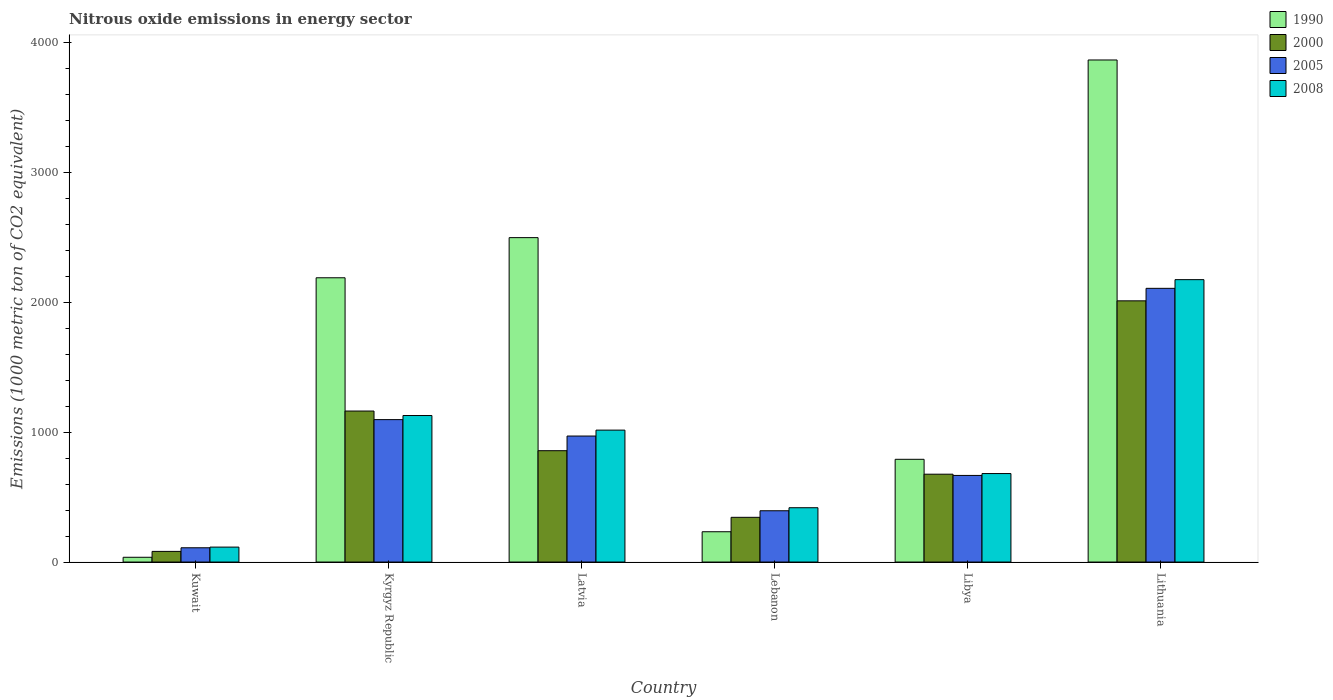How many groups of bars are there?
Give a very brief answer. 6. Are the number of bars per tick equal to the number of legend labels?
Give a very brief answer. Yes. Are the number of bars on each tick of the X-axis equal?
Give a very brief answer. Yes. How many bars are there on the 5th tick from the left?
Offer a terse response. 4. How many bars are there on the 3rd tick from the right?
Provide a succinct answer. 4. What is the label of the 4th group of bars from the left?
Offer a very short reply. Lebanon. In how many cases, is the number of bars for a given country not equal to the number of legend labels?
Your answer should be compact. 0. What is the amount of nitrous oxide emitted in 2008 in Latvia?
Your response must be concise. 1015.5. Across all countries, what is the maximum amount of nitrous oxide emitted in 2005?
Your answer should be very brief. 2107. Across all countries, what is the minimum amount of nitrous oxide emitted in 2005?
Ensure brevity in your answer.  109.8. In which country was the amount of nitrous oxide emitted in 1990 maximum?
Keep it short and to the point. Lithuania. In which country was the amount of nitrous oxide emitted in 2000 minimum?
Keep it short and to the point. Kuwait. What is the total amount of nitrous oxide emitted in 2005 in the graph?
Your response must be concise. 5344.6. What is the difference between the amount of nitrous oxide emitted in 2000 in Kyrgyz Republic and that in Libya?
Offer a terse response. 486.2. What is the difference between the amount of nitrous oxide emitted in 2008 in Kuwait and the amount of nitrous oxide emitted in 2005 in Lebanon?
Make the answer very short. -279.8. What is the average amount of nitrous oxide emitted in 1990 per country?
Make the answer very short. 1601.9. What is the difference between the amount of nitrous oxide emitted of/in 2005 and amount of nitrous oxide emitted of/in 1990 in Kyrgyz Republic?
Offer a terse response. -1091.9. What is the ratio of the amount of nitrous oxide emitted in 2008 in Kyrgyz Republic to that in Latvia?
Make the answer very short. 1.11. What is the difference between the highest and the second highest amount of nitrous oxide emitted in 2008?
Ensure brevity in your answer.  -1158.4. What is the difference between the highest and the lowest amount of nitrous oxide emitted in 2005?
Provide a short and direct response. 1997.2. In how many countries, is the amount of nitrous oxide emitted in 2008 greater than the average amount of nitrous oxide emitted in 2008 taken over all countries?
Offer a terse response. 3. Is the sum of the amount of nitrous oxide emitted in 2008 in Lebanon and Lithuania greater than the maximum amount of nitrous oxide emitted in 2005 across all countries?
Give a very brief answer. Yes. Is it the case that in every country, the sum of the amount of nitrous oxide emitted in 2005 and amount of nitrous oxide emitted in 2008 is greater than the sum of amount of nitrous oxide emitted in 1990 and amount of nitrous oxide emitted in 2000?
Make the answer very short. No. What does the 3rd bar from the right in Kuwait represents?
Give a very brief answer. 2000. How many bars are there?
Offer a terse response. 24. Are all the bars in the graph horizontal?
Offer a very short reply. No. How many countries are there in the graph?
Your answer should be very brief. 6. Are the values on the major ticks of Y-axis written in scientific E-notation?
Provide a short and direct response. No. Does the graph contain grids?
Make the answer very short. No. How many legend labels are there?
Give a very brief answer. 4. What is the title of the graph?
Make the answer very short. Nitrous oxide emissions in energy sector. What is the label or title of the Y-axis?
Offer a terse response. Emissions (1000 metric ton of CO2 equivalent). What is the Emissions (1000 metric ton of CO2 equivalent) in 1990 in Kuwait?
Offer a terse response. 36.7. What is the Emissions (1000 metric ton of CO2 equivalent) of 2000 in Kuwait?
Offer a terse response. 81.9. What is the Emissions (1000 metric ton of CO2 equivalent) of 2005 in Kuwait?
Offer a very short reply. 109.8. What is the Emissions (1000 metric ton of CO2 equivalent) in 2008 in Kuwait?
Provide a short and direct response. 114.9. What is the Emissions (1000 metric ton of CO2 equivalent) of 1990 in Kyrgyz Republic?
Keep it short and to the point. 2188.3. What is the Emissions (1000 metric ton of CO2 equivalent) of 2000 in Kyrgyz Republic?
Offer a very short reply. 1162.4. What is the Emissions (1000 metric ton of CO2 equivalent) of 2005 in Kyrgyz Republic?
Provide a short and direct response. 1096.4. What is the Emissions (1000 metric ton of CO2 equivalent) in 2008 in Kyrgyz Republic?
Offer a very short reply. 1127.9. What is the Emissions (1000 metric ton of CO2 equivalent) of 1990 in Latvia?
Keep it short and to the point. 2497.4. What is the Emissions (1000 metric ton of CO2 equivalent) in 2000 in Latvia?
Offer a terse response. 857.1. What is the Emissions (1000 metric ton of CO2 equivalent) of 2005 in Latvia?
Provide a short and direct response. 970. What is the Emissions (1000 metric ton of CO2 equivalent) of 2008 in Latvia?
Offer a terse response. 1015.5. What is the Emissions (1000 metric ton of CO2 equivalent) in 1990 in Lebanon?
Your answer should be compact. 233.2. What is the Emissions (1000 metric ton of CO2 equivalent) of 2000 in Lebanon?
Your response must be concise. 344.2. What is the Emissions (1000 metric ton of CO2 equivalent) in 2005 in Lebanon?
Your answer should be compact. 394.7. What is the Emissions (1000 metric ton of CO2 equivalent) of 2008 in Lebanon?
Provide a short and direct response. 418.1. What is the Emissions (1000 metric ton of CO2 equivalent) in 1990 in Libya?
Keep it short and to the point. 790.8. What is the Emissions (1000 metric ton of CO2 equivalent) in 2000 in Libya?
Your answer should be very brief. 676.2. What is the Emissions (1000 metric ton of CO2 equivalent) of 2005 in Libya?
Ensure brevity in your answer.  666.7. What is the Emissions (1000 metric ton of CO2 equivalent) in 2008 in Libya?
Keep it short and to the point. 681.1. What is the Emissions (1000 metric ton of CO2 equivalent) of 1990 in Lithuania?
Make the answer very short. 3865. What is the Emissions (1000 metric ton of CO2 equivalent) in 2000 in Lithuania?
Your response must be concise. 2010.8. What is the Emissions (1000 metric ton of CO2 equivalent) in 2005 in Lithuania?
Provide a succinct answer. 2107. What is the Emissions (1000 metric ton of CO2 equivalent) of 2008 in Lithuania?
Provide a succinct answer. 2173.9. Across all countries, what is the maximum Emissions (1000 metric ton of CO2 equivalent) in 1990?
Your answer should be very brief. 3865. Across all countries, what is the maximum Emissions (1000 metric ton of CO2 equivalent) of 2000?
Keep it short and to the point. 2010.8. Across all countries, what is the maximum Emissions (1000 metric ton of CO2 equivalent) of 2005?
Make the answer very short. 2107. Across all countries, what is the maximum Emissions (1000 metric ton of CO2 equivalent) in 2008?
Provide a short and direct response. 2173.9. Across all countries, what is the minimum Emissions (1000 metric ton of CO2 equivalent) of 1990?
Provide a short and direct response. 36.7. Across all countries, what is the minimum Emissions (1000 metric ton of CO2 equivalent) in 2000?
Make the answer very short. 81.9. Across all countries, what is the minimum Emissions (1000 metric ton of CO2 equivalent) of 2005?
Provide a succinct answer. 109.8. Across all countries, what is the minimum Emissions (1000 metric ton of CO2 equivalent) of 2008?
Give a very brief answer. 114.9. What is the total Emissions (1000 metric ton of CO2 equivalent) in 1990 in the graph?
Your answer should be very brief. 9611.4. What is the total Emissions (1000 metric ton of CO2 equivalent) in 2000 in the graph?
Your answer should be very brief. 5132.6. What is the total Emissions (1000 metric ton of CO2 equivalent) of 2005 in the graph?
Your answer should be compact. 5344.6. What is the total Emissions (1000 metric ton of CO2 equivalent) in 2008 in the graph?
Your response must be concise. 5531.4. What is the difference between the Emissions (1000 metric ton of CO2 equivalent) of 1990 in Kuwait and that in Kyrgyz Republic?
Ensure brevity in your answer.  -2151.6. What is the difference between the Emissions (1000 metric ton of CO2 equivalent) of 2000 in Kuwait and that in Kyrgyz Republic?
Provide a succinct answer. -1080.5. What is the difference between the Emissions (1000 metric ton of CO2 equivalent) of 2005 in Kuwait and that in Kyrgyz Republic?
Your response must be concise. -986.6. What is the difference between the Emissions (1000 metric ton of CO2 equivalent) of 2008 in Kuwait and that in Kyrgyz Republic?
Provide a succinct answer. -1013. What is the difference between the Emissions (1000 metric ton of CO2 equivalent) in 1990 in Kuwait and that in Latvia?
Give a very brief answer. -2460.7. What is the difference between the Emissions (1000 metric ton of CO2 equivalent) of 2000 in Kuwait and that in Latvia?
Your response must be concise. -775.2. What is the difference between the Emissions (1000 metric ton of CO2 equivalent) of 2005 in Kuwait and that in Latvia?
Your answer should be very brief. -860.2. What is the difference between the Emissions (1000 metric ton of CO2 equivalent) in 2008 in Kuwait and that in Latvia?
Offer a terse response. -900.6. What is the difference between the Emissions (1000 metric ton of CO2 equivalent) of 1990 in Kuwait and that in Lebanon?
Your answer should be very brief. -196.5. What is the difference between the Emissions (1000 metric ton of CO2 equivalent) of 2000 in Kuwait and that in Lebanon?
Ensure brevity in your answer.  -262.3. What is the difference between the Emissions (1000 metric ton of CO2 equivalent) of 2005 in Kuwait and that in Lebanon?
Your answer should be compact. -284.9. What is the difference between the Emissions (1000 metric ton of CO2 equivalent) of 2008 in Kuwait and that in Lebanon?
Offer a terse response. -303.2. What is the difference between the Emissions (1000 metric ton of CO2 equivalent) of 1990 in Kuwait and that in Libya?
Your answer should be very brief. -754.1. What is the difference between the Emissions (1000 metric ton of CO2 equivalent) of 2000 in Kuwait and that in Libya?
Your response must be concise. -594.3. What is the difference between the Emissions (1000 metric ton of CO2 equivalent) of 2005 in Kuwait and that in Libya?
Offer a terse response. -556.9. What is the difference between the Emissions (1000 metric ton of CO2 equivalent) of 2008 in Kuwait and that in Libya?
Your response must be concise. -566.2. What is the difference between the Emissions (1000 metric ton of CO2 equivalent) of 1990 in Kuwait and that in Lithuania?
Your answer should be compact. -3828.3. What is the difference between the Emissions (1000 metric ton of CO2 equivalent) of 2000 in Kuwait and that in Lithuania?
Your response must be concise. -1928.9. What is the difference between the Emissions (1000 metric ton of CO2 equivalent) of 2005 in Kuwait and that in Lithuania?
Ensure brevity in your answer.  -1997.2. What is the difference between the Emissions (1000 metric ton of CO2 equivalent) of 2008 in Kuwait and that in Lithuania?
Give a very brief answer. -2059. What is the difference between the Emissions (1000 metric ton of CO2 equivalent) in 1990 in Kyrgyz Republic and that in Latvia?
Your answer should be compact. -309.1. What is the difference between the Emissions (1000 metric ton of CO2 equivalent) of 2000 in Kyrgyz Republic and that in Latvia?
Offer a terse response. 305.3. What is the difference between the Emissions (1000 metric ton of CO2 equivalent) in 2005 in Kyrgyz Republic and that in Latvia?
Your answer should be very brief. 126.4. What is the difference between the Emissions (1000 metric ton of CO2 equivalent) of 2008 in Kyrgyz Republic and that in Latvia?
Provide a succinct answer. 112.4. What is the difference between the Emissions (1000 metric ton of CO2 equivalent) of 1990 in Kyrgyz Republic and that in Lebanon?
Offer a very short reply. 1955.1. What is the difference between the Emissions (1000 metric ton of CO2 equivalent) in 2000 in Kyrgyz Republic and that in Lebanon?
Provide a short and direct response. 818.2. What is the difference between the Emissions (1000 metric ton of CO2 equivalent) of 2005 in Kyrgyz Republic and that in Lebanon?
Offer a terse response. 701.7. What is the difference between the Emissions (1000 metric ton of CO2 equivalent) of 2008 in Kyrgyz Republic and that in Lebanon?
Your answer should be very brief. 709.8. What is the difference between the Emissions (1000 metric ton of CO2 equivalent) in 1990 in Kyrgyz Republic and that in Libya?
Make the answer very short. 1397.5. What is the difference between the Emissions (1000 metric ton of CO2 equivalent) in 2000 in Kyrgyz Republic and that in Libya?
Offer a terse response. 486.2. What is the difference between the Emissions (1000 metric ton of CO2 equivalent) in 2005 in Kyrgyz Republic and that in Libya?
Your response must be concise. 429.7. What is the difference between the Emissions (1000 metric ton of CO2 equivalent) of 2008 in Kyrgyz Republic and that in Libya?
Provide a succinct answer. 446.8. What is the difference between the Emissions (1000 metric ton of CO2 equivalent) of 1990 in Kyrgyz Republic and that in Lithuania?
Your answer should be compact. -1676.7. What is the difference between the Emissions (1000 metric ton of CO2 equivalent) in 2000 in Kyrgyz Republic and that in Lithuania?
Provide a short and direct response. -848.4. What is the difference between the Emissions (1000 metric ton of CO2 equivalent) in 2005 in Kyrgyz Republic and that in Lithuania?
Your response must be concise. -1010.6. What is the difference between the Emissions (1000 metric ton of CO2 equivalent) in 2008 in Kyrgyz Republic and that in Lithuania?
Offer a very short reply. -1046. What is the difference between the Emissions (1000 metric ton of CO2 equivalent) in 1990 in Latvia and that in Lebanon?
Keep it short and to the point. 2264.2. What is the difference between the Emissions (1000 metric ton of CO2 equivalent) in 2000 in Latvia and that in Lebanon?
Your answer should be compact. 512.9. What is the difference between the Emissions (1000 metric ton of CO2 equivalent) in 2005 in Latvia and that in Lebanon?
Provide a short and direct response. 575.3. What is the difference between the Emissions (1000 metric ton of CO2 equivalent) of 2008 in Latvia and that in Lebanon?
Provide a succinct answer. 597.4. What is the difference between the Emissions (1000 metric ton of CO2 equivalent) of 1990 in Latvia and that in Libya?
Offer a very short reply. 1706.6. What is the difference between the Emissions (1000 metric ton of CO2 equivalent) in 2000 in Latvia and that in Libya?
Offer a terse response. 180.9. What is the difference between the Emissions (1000 metric ton of CO2 equivalent) in 2005 in Latvia and that in Libya?
Your answer should be compact. 303.3. What is the difference between the Emissions (1000 metric ton of CO2 equivalent) in 2008 in Latvia and that in Libya?
Your answer should be very brief. 334.4. What is the difference between the Emissions (1000 metric ton of CO2 equivalent) in 1990 in Latvia and that in Lithuania?
Your answer should be very brief. -1367.6. What is the difference between the Emissions (1000 metric ton of CO2 equivalent) in 2000 in Latvia and that in Lithuania?
Offer a terse response. -1153.7. What is the difference between the Emissions (1000 metric ton of CO2 equivalent) in 2005 in Latvia and that in Lithuania?
Your answer should be compact. -1137. What is the difference between the Emissions (1000 metric ton of CO2 equivalent) of 2008 in Latvia and that in Lithuania?
Offer a terse response. -1158.4. What is the difference between the Emissions (1000 metric ton of CO2 equivalent) of 1990 in Lebanon and that in Libya?
Your answer should be very brief. -557.6. What is the difference between the Emissions (1000 metric ton of CO2 equivalent) in 2000 in Lebanon and that in Libya?
Provide a short and direct response. -332. What is the difference between the Emissions (1000 metric ton of CO2 equivalent) of 2005 in Lebanon and that in Libya?
Your answer should be very brief. -272. What is the difference between the Emissions (1000 metric ton of CO2 equivalent) of 2008 in Lebanon and that in Libya?
Give a very brief answer. -263. What is the difference between the Emissions (1000 metric ton of CO2 equivalent) of 1990 in Lebanon and that in Lithuania?
Provide a succinct answer. -3631.8. What is the difference between the Emissions (1000 metric ton of CO2 equivalent) of 2000 in Lebanon and that in Lithuania?
Provide a succinct answer. -1666.6. What is the difference between the Emissions (1000 metric ton of CO2 equivalent) of 2005 in Lebanon and that in Lithuania?
Offer a very short reply. -1712.3. What is the difference between the Emissions (1000 metric ton of CO2 equivalent) in 2008 in Lebanon and that in Lithuania?
Give a very brief answer. -1755.8. What is the difference between the Emissions (1000 metric ton of CO2 equivalent) of 1990 in Libya and that in Lithuania?
Provide a short and direct response. -3074.2. What is the difference between the Emissions (1000 metric ton of CO2 equivalent) in 2000 in Libya and that in Lithuania?
Offer a very short reply. -1334.6. What is the difference between the Emissions (1000 metric ton of CO2 equivalent) in 2005 in Libya and that in Lithuania?
Provide a succinct answer. -1440.3. What is the difference between the Emissions (1000 metric ton of CO2 equivalent) of 2008 in Libya and that in Lithuania?
Offer a terse response. -1492.8. What is the difference between the Emissions (1000 metric ton of CO2 equivalent) of 1990 in Kuwait and the Emissions (1000 metric ton of CO2 equivalent) of 2000 in Kyrgyz Republic?
Offer a terse response. -1125.7. What is the difference between the Emissions (1000 metric ton of CO2 equivalent) of 1990 in Kuwait and the Emissions (1000 metric ton of CO2 equivalent) of 2005 in Kyrgyz Republic?
Your response must be concise. -1059.7. What is the difference between the Emissions (1000 metric ton of CO2 equivalent) in 1990 in Kuwait and the Emissions (1000 metric ton of CO2 equivalent) in 2008 in Kyrgyz Republic?
Keep it short and to the point. -1091.2. What is the difference between the Emissions (1000 metric ton of CO2 equivalent) of 2000 in Kuwait and the Emissions (1000 metric ton of CO2 equivalent) of 2005 in Kyrgyz Republic?
Ensure brevity in your answer.  -1014.5. What is the difference between the Emissions (1000 metric ton of CO2 equivalent) in 2000 in Kuwait and the Emissions (1000 metric ton of CO2 equivalent) in 2008 in Kyrgyz Republic?
Give a very brief answer. -1046. What is the difference between the Emissions (1000 metric ton of CO2 equivalent) in 2005 in Kuwait and the Emissions (1000 metric ton of CO2 equivalent) in 2008 in Kyrgyz Republic?
Your answer should be compact. -1018.1. What is the difference between the Emissions (1000 metric ton of CO2 equivalent) of 1990 in Kuwait and the Emissions (1000 metric ton of CO2 equivalent) of 2000 in Latvia?
Keep it short and to the point. -820.4. What is the difference between the Emissions (1000 metric ton of CO2 equivalent) in 1990 in Kuwait and the Emissions (1000 metric ton of CO2 equivalent) in 2005 in Latvia?
Make the answer very short. -933.3. What is the difference between the Emissions (1000 metric ton of CO2 equivalent) in 1990 in Kuwait and the Emissions (1000 metric ton of CO2 equivalent) in 2008 in Latvia?
Your response must be concise. -978.8. What is the difference between the Emissions (1000 metric ton of CO2 equivalent) in 2000 in Kuwait and the Emissions (1000 metric ton of CO2 equivalent) in 2005 in Latvia?
Ensure brevity in your answer.  -888.1. What is the difference between the Emissions (1000 metric ton of CO2 equivalent) in 2000 in Kuwait and the Emissions (1000 metric ton of CO2 equivalent) in 2008 in Latvia?
Your answer should be very brief. -933.6. What is the difference between the Emissions (1000 metric ton of CO2 equivalent) in 2005 in Kuwait and the Emissions (1000 metric ton of CO2 equivalent) in 2008 in Latvia?
Ensure brevity in your answer.  -905.7. What is the difference between the Emissions (1000 metric ton of CO2 equivalent) in 1990 in Kuwait and the Emissions (1000 metric ton of CO2 equivalent) in 2000 in Lebanon?
Ensure brevity in your answer.  -307.5. What is the difference between the Emissions (1000 metric ton of CO2 equivalent) of 1990 in Kuwait and the Emissions (1000 metric ton of CO2 equivalent) of 2005 in Lebanon?
Keep it short and to the point. -358. What is the difference between the Emissions (1000 metric ton of CO2 equivalent) of 1990 in Kuwait and the Emissions (1000 metric ton of CO2 equivalent) of 2008 in Lebanon?
Your response must be concise. -381.4. What is the difference between the Emissions (1000 metric ton of CO2 equivalent) in 2000 in Kuwait and the Emissions (1000 metric ton of CO2 equivalent) in 2005 in Lebanon?
Your response must be concise. -312.8. What is the difference between the Emissions (1000 metric ton of CO2 equivalent) in 2000 in Kuwait and the Emissions (1000 metric ton of CO2 equivalent) in 2008 in Lebanon?
Offer a terse response. -336.2. What is the difference between the Emissions (1000 metric ton of CO2 equivalent) in 2005 in Kuwait and the Emissions (1000 metric ton of CO2 equivalent) in 2008 in Lebanon?
Give a very brief answer. -308.3. What is the difference between the Emissions (1000 metric ton of CO2 equivalent) of 1990 in Kuwait and the Emissions (1000 metric ton of CO2 equivalent) of 2000 in Libya?
Make the answer very short. -639.5. What is the difference between the Emissions (1000 metric ton of CO2 equivalent) in 1990 in Kuwait and the Emissions (1000 metric ton of CO2 equivalent) in 2005 in Libya?
Offer a very short reply. -630. What is the difference between the Emissions (1000 metric ton of CO2 equivalent) in 1990 in Kuwait and the Emissions (1000 metric ton of CO2 equivalent) in 2008 in Libya?
Make the answer very short. -644.4. What is the difference between the Emissions (1000 metric ton of CO2 equivalent) in 2000 in Kuwait and the Emissions (1000 metric ton of CO2 equivalent) in 2005 in Libya?
Provide a succinct answer. -584.8. What is the difference between the Emissions (1000 metric ton of CO2 equivalent) of 2000 in Kuwait and the Emissions (1000 metric ton of CO2 equivalent) of 2008 in Libya?
Offer a terse response. -599.2. What is the difference between the Emissions (1000 metric ton of CO2 equivalent) in 2005 in Kuwait and the Emissions (1000 metric ton of CO2 equivalent) in 2008 in Libya?
Provide a short and direct response. -571.3. What is the difference between the Emissions (1000 metric ton of CO2 equivalent) in 1990 in Kuwait and the Emissions (1000 metric ton of CO2 equivalent) in 2000 in Lithuania?
Provide a short and direct response. -1974.1. What is the difference between the Emissions (1000 metric ton of CO2 equivalent) of 1990 in Kuwait and the Emissions (1000 metric ton of CO2 equivalent) of 2005 in Lithuania?
Give a very brief answer. -2070.3. What is the difference between the Emissions (1000 metric ton of CO2 equivalent) in 1990 in Kuwait and the Emissions (1000 metric ton of CO2 equivalent) in 2008 in Lithuania?
Make the answer very short. -2137.2. What is the difference between the Emissions (1000 metric ton of CO2 equivalent) in 2000 in Kuwait and the Emissions (1000 metric ton of CO2 equivalent) in 2005 in Lithuania?
Make the answer very short. -2025.1. What is the difference between the Emissions (1000 metric ton of CO2 equivalent) in 2000 in Kuwait and the Emissions (1000 metric ton of CO2 equivalent) in 2008 in Lithuania?
Provide a succinct answer. -2092. What is the difference between the Emissions (1000 metric ton of CO2 equivalent) in 2005 in Kuwait and the Emissions (1000 metric ton of CO2 equivalent) in 2008 in Lithuania?
Your response must be concise. -2064.1. What is the difference between the Emissions (1000 metric ton of CO2 equivalent) of 1990 in Kyrgyz Republic and the Emissions (1000 metric ton of CO2 equivalent) of 2000 in Latvia?
Give a very brief answer. 1331.2. What is the difference between the Emissions (1000 metric ton of CO2 equivalent) of 1990 in Kyrgyz Republic and the Emissions (1000 metric ton of CO2 equivalent) of 2005 in Latvia?
Your answer should be compact. 1218.3. What is the difference between the Emissions (1000 metric ton of CO2 equivalent) of 1990 in Kyrgyz Republic and the Emissions (1000 metric ton of CO2 equivalent) of 2008 in Latvia?
Ensure brevity in your answer.  1172.8. What is the difference between the Emissions (1000 metric ton of CO2 equivalent) of 2000 in Kyrgyz Republic and the Emissions (1000 metric ton of CO2 equivalent) of 2005 in Latvia?
Offer a very short reply. 192.4. What is the difference between the Emissions (1000 metric ton of CO2 equivalent) of 2000 in Kyrgyz Republic and the Emissions (1000 metric ton of CO2 equivalent) of 2008 in Latvia?
Provide a succinct answer. 146.9. What is the difference between the Emissions (1000 metric ton of CO2 equivalent) of 2005 in Kyrgyz Republic and the Emissions (1000 metric ton of CO2 equivalent) of 2008 in Latvia?
Make the answer very short. 80.9. What is the difference between the Emissions (1000 metric ton of CO2 equivalent) in 1990 in Kyrgyz Republic and the Emissions (1000 metric ton of CO2 equivalent) in 2000 in Lebanon?
Your response must be concise. 1844.1. What is the difference between the Emissions (1000 metric ton of CO2 equivalent) of 1990 in Kyrgyz Republic and the Emissions (1000 metric ton of CO2 equivalent) of 2005 in Lebanon?
Make the answer very short. 1793.6. What is the difference between the Emissions (1000 metric ton of CO2 equivalent) of 1990 in Kyrgyz Republic and the Emissions (1000 metric ton of CO2 equivalent) of 2008 in Lebanon?
Provide a succinct answer. 1770.2. What is the difference between the Emissions (1000 metric ton of CO2 equivalent) of 2000 in Kyrgyz Republic and the Emissions (1000 metric ton of CO2 equivalent) of 2005 in Lebanon?
Keep it short and to the point. 767.7. What is the difference between the Emissions (1000 metric ton of CO2 equivalent) in 2000 in Kyrgyz Republic and the Emissions (1000 metric ton of CO2 equivalent) in 2008 in Lebanon?
Keep it short and to the point. 744.3. What is the difference between the Emissions (1000 metric ton of CO2 equivalent) in 2005 in Kyrgyz Republic and the Emissions (1000 metric ton of CO2 equivalent) in 2008 in Lebanon?
Your answer should be compact. 678.3. What is the difference between the Emissions (1000 metric ton of CO2 equivalent) in 1990 in Kyrgyz Republic and the Emissions (1000 metric ton of CO2 equivalent) in 2000 in Libya?
Provide a succinct answer. 1512.1. What is the difference between the Emissions (1000 metric ton of CO2 equivalent) of 1990 in Kyrgyz Republic and the Emissions (1000 metric ton of CO2 equivalent) of 2005 in Libya?
Your answer should be very brief. 1521.6. What is the difference between the Emissions (1000 metric ton of CO2 equivalent) of 1990 in Kyrgyz Republic and the Emissions (1000 metric ton of CO2 equivalent) of 2008 in Libya?
Your response must be concise. 1507.2. What is the difference between the Emissions (1000 metric ton of CO2 equivalent) of 2000 in Kyrgyz Republic and the Emissions (1000 metric ton of CO2 equivalent) of 2005 in Libya?
Your answer should be compact. 495.7. What is the difference between the Emissions (1000 metric ton of CO2 equivalent) of 2000 in Kyrgyz Republic and the Emissions (1000 metric ton of CO2 equivalent) of 2008 in Libya?
Your answer should be very brief. 481.3. What is the difference between the Emissions (1000 metric ton of CO2 equivalent) of 2005 in Kyrgyz Republic and the Emissions (1000 metric ton of CO2 equivalent) of 2008 in Libya?
Keep it short and to the point. 415.3. What is the difference between the Emissions (1000 metric ton of CO2 equivalent) of 1990 in Kyrgyz Republic and the Emissions (1000 metric ton of CO2 equivalent) of 2000 in Lithuania?
Provide a succinct answer. 177.5. What is the difference between the Emissions (1000 metric ton of CO2 equivalent) in 1990 in Kyrgyz Republic and the Emissions (1000 metric ton of CO2 equivalent) in 2005 in Lithuania?
Offer a terse response. 81.3. What is the difference between the Emissions (1000 metric ton of CO2 equivalent) of 1990 in Kyrgyz Republic and the Emissions (1000 metric ton of CO2 equivalent) of 2008 in Lithuania?
Your answer should be compact. 14.4. What is the difference between the Emissions (1000 metric ton of CO2 equivalent) in 2000 in Kyrgyz Republic and the Emissions (1000 metric ton of CO2 equivalent) in 2005 in Lithuania?
Give a very brief answer. -944.6. What is the difference between the Emissions (1000 metric ton of CO2 equivalent) in 2000 in Kyrgyz Republic and the Emissions (1000 metric ton of CO2 equivalent) in 2008 in Lithuania?
Provide a short and direct response. -1011.5. What is the difference between the Emissions (1000 metric ton of CO2 equivalent) of 2005 in Kyrgyz Republic and the Emissions (1000 metric ton of CO2 equivalent) of 2008 in Lithuania?
Your answer should be very brief. -1077.5. What is the difference between the Emissions (1000 metric ton of CO2 equivalent) of 1990 in Latvia and the Emissions (1000 metric ton of CO2 equivalent) of 2000 in Lebanon?
Ensure brevity in your answer.  2153.2. What is the difference between the Emissions (1000 metric ton of CO2 equivalent) in 1990 in Latvia and the Emissions (1000 metric ton of CO2 equivalent) in 2005 in Lebanon?
Your response must be concise. 2102.7. What is the difference between the Emissions (1000 metric ton of CO2 equivalent) in 1990 in Latvia and the Emissions (1000 metric ton of CO2 equivalent) in 2008 in Lebanon?
Give a very brief answer. 2079.3. What is the difference between the Emissions (1000 metric ton of CO2 equivalent) of 2000 in Latvia and the Emissions (1000 metric ton of CO2 equivalent) of 2005 in Lebanon?
Give a very brief answer. 462.4. What is the difference between the Emissions (1000 metric ton of CO2 equivalent) of 2000 in Latvia and the Emissions (1000 metric ton of CO2 equivalent) of 2008 in Lebanon?
Offer a terse response. 439. What is the difference between the Emissions (1000 metric ton of CO2 equivalent) of 2005 in Latvia and the Emissions (1000 metric ton of CO2 equivalent) of 2008 in Lebanon?
Your response must be concise. 551.9. What is the difference between the Emissions (1000 metric ton of CO2 equivalent) of 1990 in Latvia and the Emissions (1000 metric ton of CO2 equivalent) of 2000 in Libya?
Keep it short and to the point. 1821.2. What is the difference between the Emissions (1000 metric ton of CO2 equivalent) in 1990 in Latvia and the Emissions (1000 metric ton of CO2 equivalent) in 2005 in Libya?
Offer a terse response. 1830.7. What is the difference between the Emissions (1000 metric ton of CO2 equivalent) in 1990 in Latvia and the Emissions (1000 metric ton of CO2 equivalent) in 2008 in Libya?
Your answer should be very brief. 1816.3. What is the difference between the Emissions (1000 metric ton of CO2 equivalent) in 2000 in Latvia and the Emissions (1000 metric ton of CO2 equivalent) in 2005 in Libya?
Offer a terse response. 190.4. What is the difference between the Emissions (1000 metric ton of CO2 equivalent) of 2000 in Latvia and the Emissions (1000 metric ton of CO2 equivalent) of 2008 in Libya?
Keep it short and to the point. 176. What is the difference between the Emissions (1000 metric ton of CO2 equivalent) of 2005 in Latvia and the Emissions (1000 metric ton of CO2 equivalent) of 2008 in Libya?
Offer a terse response. 288.9. What is the difference between the Emissions (1000 metric ton of CO2 equivalent) of 1990 in Latvia and the Emissions (1000 metric ton of CO2 equivalent) of 2000 in Lithuania?
Make the answer very short. 486.6. What is the difference between the Emissions (1000 metric ton of CO2 equivalent) of 1990 in Latvia and the Emissions (1000 metric ton of CO2 equivalent) of 2005 in Lithuania?
Offer a terse response. 390.4. What is the difference between the Emissions (1000 metric ton of CO2 equivalent) in 1990 in Latvia and the Emissions (1000 metric ton of CO2 equivalent) in 2008 in Lithuania?
Your response must be concise. 323.5. What is the difference between the Emissions (1000 metric ton of CO2 equivalent) of 2000 in Latvia and the Emissions (1000 metric ton of CO2 equivalent) of 2005 in Lithuania?
Give a very brief answer. -1249.9. What is the difference between the Emissions (1000 metric ton of CO2 equivalent) of 2000 in Latvia and the Emissions (1000 metric ton of CO2 equivalent) of 2008 in Lithuania?
Ensure brevity in your answer.  -1316.8. What is the difference between the Emissions (1000 metric ton of CO2 equivalent) in 2005 in Latvia and the Emissions (1000 metric ton of CO2 equivalent) in 2008 in Lithuania?
Provide a succinct answer. -1203.9. What is the difference between the Emissions (1000 metric ton of CO2 equivalent) of 1990 in Lebanon and the Emissions (1000 metric ton of CO2 equivalent) of 2000 in Libya?
Make the answer very short. -443. What is the difference between the Emissions (1000 metric ton of CO2 equivalent) in 1990 in Lebanon and the Emissions (1000 metric ton of CO2 equivalent) in 2005 in Libya?
Your response must be concise. -433.5. What is the difference between the Emissions (1000 metric ton of CO2 equivalent) of 1990 in Lebanon and the Emissions (1000 metric ton of CO2 equivalent) of 2008 in Libya?
Provide a succinct answer. -447.9. What is the difference between the Emissions (1000 metric ton of CO2 equivalent) of 2000 in Lebanon and the Emissions (1000 metric ton of CO2 equivalent) of 2005 in Libya?
Give a very brief answer. -322.5. What is the difference between the Emissions (1000 metric ton of CO2 equivalent) of 2000 in Lebanon and the Emissions (1000 metric ton of CO2 equivalent) of 2008 in Libya?
Offer a very short reply. -336.9. What is the difference between the Emissions (1000 metric ton of CO2 equivalent) in 2005 in Lebanon and the Emissions (1000 metric ton of CO2 equivalent) in 2008 in Libya?
Make the answer very short. -286.4. What is the difference between the Emissions (1000 metric ton of CO2 equivalent) of 1990 in Lebanon and the Emissions (1000 metric ton of CO2 equivalent) of 2000 in Lithuania?
Provide a short and direct response. -1777.6. What is the difference between the Emissions (1000 metric ton of CO2 equivalent) in 1990 in Lebanon and the Emissions (1000 metric ton of CO2 equivalent) in 2005 in Lithuania?
Your response must be concise. -1873.8. What is the difference between the Emissions (1000 metric ton of CO2 equivalent) in 1990 in Lebanon and the Emissions (1000 metric ton of CO2 equivalent) in 2008 in Lithuania?
Your answer should be very brief. -1940.7. What is the difference between the Emissions (1000 metric ton of CO2 equivalent) of 2000 in Lebanon and the Emissions (1000 metric ton of CO2 equivalent) of 2005 in Lithuania?
Offer a very short reply. -1762.8. What is the difference between the Emissions (1000 metric ton of CO2 equivalent) of 2000 in Lebanon and the Emissions (1000 metric ton of CO2 equivalent) of 2008 in Lithuania?
Ensure brevity in your answer.  -1829.7. What is the difference between the Emissions (1000 metric ton of CO2 equivalent) of 2005 in Lebanon and the Emissions (1000 metric ton of CO2 equivalent) of 2008 in Lithuania?
Keep it short and to the point. -1779.2. What is the difference between the Emissions (1000 metric ton of CO2 equivalent) of 1990 in Libya and the Emissions (1000 metric ton of CO2 equivalent) of 2000 in Lithuania?
Provide a succinct answer. -1220. What is the difference between the Emissions (1000 metric ton of CO2 equivalent) of 1990 in Libya and the Emissions (1000 metric ton of CO2 equivalent) of 2005 in Lithuania?
Give a very brief answer. -1316.2. What is the difference between the Emissions (1000 metric ton of CO2 equivalent) in 1990 in Libya and the Emissions (1000 metric ton of CO2 equivalent) in 2008 in Lithuania?
Make the answer very short. -1383.1. What is the difference between the Emissions (1000 metric ton of CO2 equivalent) of 2000 in Libya and the Emissions (1000 metric ton of CO2 equivalent) of 2005 in Lithuania?
Your response must be concise. -1430.8. What is the difference between the Emissions (1000 metric ton of CO2 equivalent) of 2000 in Libya and the Emissions (1000 metric ton of CO2 equivalent) of 2008 in Lithuania?
Ensure brevity in your answer.  -1497.7. What is the difference between the Emissions (1000 metric ton of CO2 equivalent) in 2005 in Libya and the Emissions (1000 metric ton of CO2 equivalent) in 2008 in Lithuania?
Offer a very short reply. -1507.2. What is the average Emissions (1000 metric ton of CO2 equivalent) of 1990 per country?
Make the answer very short. 1601.9. What is the average Emissions (1000 metric ton of CO2 equivalent) in 2000 per country?
Offer a terse response. 855.43. What is the average Emissions (1000 metric ton of CO2 equivalent) in 2005 per country?
Your response must be concise. 890.77. What is the average Emissions (1000 metric ton of CO2 equivalent) in 2008 per country?
Ensure brevity in your answer.  921.9. What is the difference between the Emissions (1000 metric ton of CO2 equivalent) in 1990 and Emissions (1000 metric ton of CO2 equivalent) in 2000 in Kuwait?
Provide a short and direct response. -45.2. What is the difference between the Emissions (1000 metric ton of CO2 equivalent) of 1990 and Emissions (1000 metric ton of CO2 equivalent) of 2005 in Kuwait?
Your answer should be very brief. -73.1. What is the difference between the Emissions (1000 metric ton of CO2 equivalent) in 1990 and Emissions (1000 metric ton of CO2 equivalent) in 2008 in Kuwait?
Ensure brevity in your answer.  -78.2. What is the difference between the Emissions (1000 metric ton of CO2 equivalent) in 2000 and Emissions (1000 metric ton of CO2 equivalent) in 2005 in Kuwait?
Offer a terse response. -27.9. What is the difference between the Emissions (1000 metric ton of CO2 equivalent) of 2000 and Emissions (1000 metric ton of CO2 equivalent) of 2008 in Kuwait?
Provide a succinct answer. -33. What is the difference between the Emissions (1000 metric ton of CO2 equivalent) of 1990 and Emissions (1000 metric ton of CO2 equivalent) of 2000 in Kyrgyz Republic?
Your answer should be very brief. 1025.9. What is the difference between the Emissions (1000 metric ton of CO2 equivalent) of 1990 and Emissions (1000 metric ton of CO2 equivalent) of 2005 in Kyrgyz Republic?
Give a very brief answer. 1091.9. What is the difference between the Emissions (1000 metric ton of CO2 equivalent) of 1990 and Emissions (1000 metric ton of CO2 equivalent) of 2008 in Kyrgyz Republic?
Ensure brevity in your answer.  1060.4. What is the difference between the Emissions (1000 metric ton of CO2 equivalent) of 2000 and Emissions (1000 metric ton of CO2 equivalent) of 2005 in Kyrgyz Republic?
Your answer should be compact. 66. What is the difference between the Emissions (1000 metric ton of CO2 equivalent) of 2000 and Emissions (1000 metric ton of CO2 equivalent) of 2008 in Kyrgyz Republic?
Ensure brevity in your answer.  34.5. What is the difference between the Emissions (1000 metric ton of CO2 equivalent) of 2005 and Emissions (1000 metric ton of CO2 equivalent) of 2008 in Kyrgyz Republic?
Offer a very short reply. -31.5. What is the difference between the Emissions (1000 metric ton of CO2 equivalent) of 1990 and Emissions (1000 metric ton of CO2 equivalent) of 2000 in Latvia?
Provide a short and direct response. 1640.3. What is the difference between the Emissions (1000 metric ton of CO2 equivalent) in 1990 and Emissions (1000 metric ton of CO2 equivalent) in 2005 in Latvia?
Ensure brevity in your answer.  1527.4. What is the difference between the Emissions (1000 metric ton of CO2 equivalent) of 1990 and Emissions (1000 metric ton of CO2 equivalent) of 2008 in Latvia?
Your response must be concise. 1481.9. What is the difference between the Emissions (1000 metric ton of CO2 equivalent) of 2000 and Emissions (1000 metric ton of CO2 equivalent) of 2005 in Latvia?
Provide a succinct answer. -112.9. What is the difference between the Emissions (1000 metric ton of CO2 equivalent) of 2000 and Emissions (1000 metric ton of CO2 equivalent) of 2008 in Latvia?
Ensure brevity in your answer.  -158.4. What is the difference between the Emissions (1000 metric ton of CO2 equivalent) of 2005 and Emissions (1000 metric ton of CO2 equivalent) of 2008 in Latvia?
Provide a short and direct response. -45.5. What is the difference between the Emissions (1000 metric ton of CO2 equivalent) in 1990 and Emissions (1000 metric ton of CO2 equivalent) in 2000 in Lebanon?
Ensure brevity in your answer.  -111. What is the difference between the Emissions (1000 metric ton of CO2 equivalent) of 1990 and Emissions (1000 metric ton of CO2 equivalent) of 2005 in Lebanon?
Provide a succinct answer. -161.5. What is the difference between the Emissions (1000 metric ton of CO2 equivalent) of 1990 and Emissions (1000 metric ton of CO2 equivalent) of 2008 in Lebanon?
Offer a very short reply. -184.9. What is the difference between the Emissions (1000 metric ton of CO2 equivalent) in 2000 and Emissions (1000 metric ton of CO2 equivalent) in 2005 in Lebanon?
Offer a very short reply. -50.5. What is the difference between the Emissions (1000 metric ton of CO2 equivalent) of 2000 and Emissions (1000 metric ton of CO2 equivalent) of 2008 in Lebanon?
Ensure brevity in your answer.  -73.9. What is the difference between the Emissions (1000 metric ton of CO2 equivalent) of 2005 and Emissions (1000 metric ton of CO2 equivalent) of 2008 in Lebanon?
Provide a succinct answer. -23.4. What is the difference between the Emissions (1000 metric ton of CO2 equivalent) of 1990 and Emissions (1000 metric ton of CO2 equivalent) of 2000 in Libya?
Keep it short and to the point. 114.6. What is the difference between the Emissions (1000 metric ton of CO2 equivalent) of 1990 and Emissions (1000 metric ton of CO2 equivalent) of 2005 in Libya?
Make the answer very short. 124.1. What is the difference between the Emissions (1000 metric ton of CO2 equivalent) of 1990 and Emissions (1000 metric ton of CO2 equivalent) of 2008 in Libya?
Provide a short and direct response. 109.7. What is the difference between the Emissions (1000 metric ton of CO2 equivalent) of 2000 and Emissions (1000 metric ton of CO2 equivalent) of 2005 in Libya?
Your answer should be compact. 9.5. What is the difference between the Emissions (1000 metric ton of CO2 equivalent) in 2005 and Emissions (1000 metric ton of CO2 equivalent) in 2008 in Libya?
Ensure brevity in your answer.  -14.4. What is the difference between the Emissions (1000 metric ton of CO2 equivalent) of 1990 and Emissions (1000 metric ton of CO2 equivalent) of 2000 in Lithuania?
Your answer should be compact. 1854.2. What is the difference between the Emissions (1000 metric ton of CO2 equivalent) of 1990 and Emissions (1000 metric ton of CO2 equivalent) of 2005 in Lithuania?
Your answer should be compact. 1758. What is the difference between the Emissions (1000 metric ton of CO2 equivalent) of 1990 and Emissions (1000 metric ton of CO2 equivalent) of 2008 in Lithuania?
Your answer should be compact. 1691.1. What is the difference between the Emissions (1000 metric ton of CO2 equivalent) in 2000 and Emissions (1000 metric ton of CO2 equivalent) in 2005 in Lithuania?
Provide a short and direct response. -96.2. What is the difference between the Emissions (1000 metric ton of CO2 equivalent) in 2000 and Emissions (1000 metric ton of CO2 equivalent) in 2008 in Lithuania?
Provide a short and direct response. -163.1. What is the difference between the Emissions (1000 metric ton of CO2 equivalent) in 2005 and Emissions (1000 metric ton of CO2 equivalent) in 2008 in Lithuania?
Offer a very short reply. -66.9. What is the ratio of the Emissions (1000 metric ton of CO2 equivalent) in 1990 in Kuwait to that in Kyrgyz Republic?
Offer a very short reply. 0.02. What is the ratio of the Emissions (1000 metric ton of CO2 equivalent) in 2000 in Kuwait to that in Kyrgyz Republic?
Keep it short and to the point. 0.07. What is the ratio of the Emissions (1000 metric ton of CO2 equivalent) of 2005 in Kuwait to that in Kyrgyz Republic?
Your answer should be compact. 0.1. What is the ratio of the Emissions (1000 metric ton of CO2 equivalent) in 2008 in Kuwait to that in Kyrgyz Republic?
Offer a very short reply. 0.1. What is the ratio of the Emissions (1000 metric ton of CO2 equivalent) of 1990 in Kuwait to that in Latvia?
Your answer should be compact. 0.01. What is the ratio of the Emissions (1000 metric ton of CO2 equivalent) of 2000 in Kuwait to that in Latvia?
Provide a succinct answer. 0.1. What is the ratio of the Emissions (1000 metric ton of CO2 equivalent) in 2005 in Kuwait to that in Latvia?
Make the answer very short. 0.11. What is the ratio of the Emissions (1000 metric ton of CO2 equivalent) in 2008 in Kuwait to that in Latvia?
Offer a very short reply. 0.11. What is the ratio of the Emissions (1000 metric ton of CO2 equivalent) in 1990 in Kuwait to that in Lebanon?
Offer a terse response. 0.16. What is the ratio of the Emissions (1000 metric ton of CO2 equivalent) in 2000 in Kuwait to that in Lebanon?
Give a very brief answer. 0.24. What is the ratio of the Emissions (1000 metric ton of CO2 equivalent) of 2005 in Kuwait to that in Lebanon?
Make the answer very short. 0.28. What is the ratio of the Emissions (1000 metric ton of CO2 equivalent) of 2008 in Kuwait to that in Lebanon?
Your answer should be very brief. 0.27. What is the ratio of the Emissions (1000 metric ton of CO2 equivalent) in 1990 in Kuwait to that in Libya?
Provide a short and direct response. 0.05. What is the ratio of the Emissions (1000 metric ton of CO2 equivalent) in 2000 in Kuwait to that in Libya?
Offer a terse response. 0.12. What is the ratio of the Emissions (1000 metric ton of CO2 equivalent) of 2005 in Kuwait to that in Libya?
Offer a terse response. 0.16. What is the ratio of the Emissions (1000 metric ton of CO2 equivalent) in 2008 in Kuwait to that in Libya?
Provide a short and direct response. 0.17. What is the ratio of the Emissions (1000 metric ton of CO2 equivalent) in 1990 in Kuwait to that in Lithuania?
Make the answer very short. 0.01. What is the ratio of the Emissions (1000 metric ton of CO2 equivalent) in 2000 in Kuwait to that in Lithuania?
Provide a short and direct response. 0.04. What is the ratio of the Emissions (1000 metric ton of CO2 equivalent) of 2005 in Kuwait to that in Lithuania?
Provide a succinct answer. 0.05. What is the ratio of the Emissions (1000 metric ton of CO2 equivalent) in 2008 in Kuwait to that in Lithuania?
Give a very brief answer. 0.05. What is the ratio of the Emissions (1000 metric ton of CO2 equivalent) of 1990 in Kyrgyz Republic to that in Latvia?
Provide a short and direct response. 0.88. What is the ratio of the Emissions (1000 metric ton of CO2 equivalent) in 2000 in Kyrgyz Republic to that in Latvia?
Your response must be concise. 1.36. What is the ratio of the Emissions (1000 metric ton of CO2 equivalent) in 2005 in Kyrgyz Republic to that in Latvia?
Give a very brief answer. 1.13. What is the ratio of the Emissions (1000 metric ton of CO2 equivalent) of 2008 in Kyrgyz Republic to that in Latvia?
Give a very brief answer. 1.11. What is the ratio of the Emissions (1000 metric ton of CO2 equivalent) in 1990 in Kyrgyz Republic to that in Lebanon?
Offer a very short reply. 9.38. What is the ratio of the Emissions (1000 metric ton of CO2 equivalent) in 2000 in Kyrgyz Republic to that in Lebanon?
Give a very brief answer. 3.38. What is the ratio of the Emissions (1000 metric ton of CO2 equivalent) in 2005 in Kyrgyz Republic to that in Lebanon?
Provide a succinct answer. 2.78. What is the ratio of the Emissions (1000 metric ton of CO2 equivalent) of 2008 in Kyrgyz Republic to that in Lebanon?
Provide a short and direct response. 2.7. What is the ratio of the Emissions (1000 metric ton of CO2 equivalent) in 1990 in Kyrgyz Republic to that in Libya?
Your response must be concise. 2.77. What is the ratio of the Emissions (1000 metric ton of CO2 equivalent) of 2000 in Kyrgyz Republic to that in Libya?
Your response must be concise. 1.72. What is the ratio of the Emissions (1000 metric ton of CO2 equivalent) of 2005 in Kyrgyz Republic to that in Libya?
Your response must be concise. 1.64. What is the ratio of the Emissions (1000 metric ton of CO2 equivalent) of 2008 in Kyrgyz Republic to that in Libya?
Offer a terse response. 1.66. What is the ratio of the Emissions (1000 metric ton of CO2 equivalent) of 1990 in Kyrgyz Republic to that in Lithuania?
Offer a very short reply. 0.57. What is the ratio of the Emissions (1000 metric ton of CO2 equivalent) of 2000 in Kyrgyz Republic to that in Lithuania?
Offer a very short reply. 0.58. What is the ratio of the Emissions (1000 metric ton of CO2 equivalent) in 2005 in Kyrgyz Republic to that in Lithuania?
Your answer should be compact. 0.52. What is the ratio of the Emissions (1000 metric ton of CO2 equivalent) in 2008 in Kyrgyz Republic to that in Lithuania?
Your answer should be compact. 0.52. What is the ratio of the Emissions (1000 metric ton of CO2 equivalent) of 1990 in Latvia to that in Lebanon?
Offer a terse response. 10.71. What is the ratio of the Emissions (1000 metric ton of CO2 equivalent) in 2000 in Latvia to that in Lebanon?
Offer a terse response. 2.49. What is the ratio of the Emissions (1000 metric ton of CO2 equivalent) of 2005 in Latvia to that in Lebanon?
Provide a succinct answer. 2.46. What is the ratio of the Emissions (1000 metric ton of CO2 equivalent) of 2008 in Latvia to that in Lebanon?
Offer a very short reply. 2.43. What is the ratio of the Emissions (1000 metric ton of CO2 equivalent) in 1990 in Latvia to that in Libya?
Make the answer very short. 3.16. What is the ratio of the Emissions (1000 metric ton of CO2 equivalent) in 2000 in Latvia to that in Libya?
Offer a terse response. 1.27. What is the ratio of the Emissions (1000 metric ton of CO2 equivalent) of 2005 in Latvia to that in Libya?
Ensure brevity in your answer.  1.45. What is the ratio of the Emissions (1000 metric ton of CO2 equivalent) in 2008 in Latvia to that in Libya?
Ensure brevity in your answer.  1.49. What is the ratio of the Emissions (1000 metric ton of CO2 equivalent) of 1990 in Latvia to that in Lithuania?
Keep it short and to the point. 0.65. What is the ratio of the Emissions (1000 metric ton of CO2 equivalent) in 2000 in Latvia to that in Lithuania?
Keep it short and to the point. 0.43. What is the ratio of the Emissions (1000 metric ton of CO2 equivalent) in 2005 in Latvia to that in Lithuania?
Offer a very short reply. 0.46. What is the ratio of the Emissions (1000 metric ton of CO2 equivalent) in 2008 in Latvia to that in Lithuania?
Ensure brevity in your answer.  0.47. What is the ratio of the Emissions (1000 metric ton of CO2 equivalent) of 1990 in Lebanon to that in Libya?
Provide a succinct answer. 0.29. What is the ratio of the Emissions (1000 metric ton of CO2 equivalent) in 2000 in Lebanon to that in Libya?
Offer a terse response. 0.51. What is the ratio of the Emissions (1000 metric ton of CO2 equivalent) in 2005 in Lebanon to that in Libya?
Offer a very short reply. 0.59. What is the ratio of the Emissions (1000 metric ton of CO2 equivalent) in 2008 in Lebanon to that in Libya?
Make the answer very short. 0.61. What is the ratio of the Emissions (1000 metric ton of CO2 equivalent) in 1990 in Lebanon to that in Lithuania?
Your answer should be compact. 0.06. What is the ratio of the Emissions (1000 metric ton of CO2 equivalent) in 2000 in Lebanon to that in Lithuania?
Your answer should be compact. 0.17. What is the ratio of the Emissions (1000 metric ton of CO2 equivalent) in 2005 in Lebanon to that in Lithuania?
Give a very brief answer. 0.19. What is the ratio of the Emissions (1000 metric ton of CO2 equivalent) of 2008 in Lebanon to that in Lithuania?
Keep it short and to the point. 0.19. What is the ratio of the Emissions (1000 metric ton of CO2 equivalent) in 1990 in Libya to that in Lithuania?
Ensure brevity in your answer.  0.2. What is the ratio of the Emissions (1000 metric ton of CO2 equivalent) of 2000 in Libya to that in Lithuania?
Give a very brief answer. 0.34. What is the ratio of the Emissions (1000 metric ton of CO2 equivalent) in 2005 in Libya to that in Lithuania?
Make the answer very short. 0.32. What is the ratio of the Emissions (1000 metric ton of CO2 equivalent) in 2008 in Libya to that in Lithuania?
Ensure brevity in your answer.  0.31. What is the difference between the highest and the second highest Emissions (1000 metric ton of CO2 equivalent) of 1990?
Ensure brevity in your answer.  1367.6. What is the difference between the highest and the second highest Emissions (1000 metric ton of CO2 equivalent) of 2000?
Keep it short and to the point. 848.4. What is the difference between the highest and the second highest Emissions (1000 metric ton of CO2 equivalent) of 2005?
Keep it short and to the point. 1010.6. What is the difference between the highest and the second highest Emissions (1000 metric ton of CO2 equivalent) of 2008?
Keep it short and to the point. 1046. What is the difference between the highest and the lowest Emissions (1000 metric ton of CO2 equivalent) of 1990?
Your answer should be very brief. 3828.3. What is the difference between the highest and the lowest Emissions (1000 metric ton of CO2 equivalent) of 2000?
Offer a terse response. 1928.9. What is the difference between the highest and the lowest Emissions (1000 metric ton of CO2 equivalent) in 2005?
Make the answer very short. 1997.2. What is the difference between the highest and the lowest Emissions (1000 metric ton of CO2 equivalent) in 2008?
Offer a terse response. 2059. 